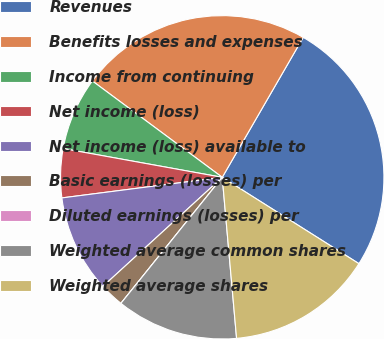Convert chart. <chart><loc_0><loc_0><loc_500><loc_500><pie_chart><fcel>Revenues<fcel>Benefits losses and expenses<fcel>Income from continuing<fcel>Net income (loss)<fcel>Net income (loss) available to<fcel>Basic earnings (losses) per<fcel>Diluted earnings (losses) per<fcel>Weighted average common shares<fcel>Weighted average shares<nl><fcel>25.62%<fcel>23.19%<fcel>7.31%<fcel>4.88%<fcel>9.75%<fcel>2.44%<fcel>0.0%<fcel>12.19%<fcel>14.62%<nl></chart> 